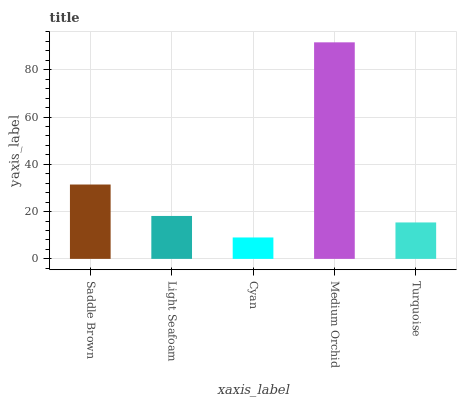Is Cyan the minimum?
Answer yes or no. Yes. Is Medium Orchid the maximum?
Answer yes or no. Yes. Is Light Seafoam the minimum?
Answer yes or no. No. Is Light Seafoam the maximum?
Answer yes or no. No. Is Saddle Brown greater than Light Seafoam?
Answer yes or no. Yes. Is Light Seafoam less than Saddle Brown?
Answer yes or no. Yes. Is Light Seafoam greater than Saddle Brown?
Answer yes or no. No. Is Saddle Brown less than Light Seafoam?
Answer yes or no. No. Is Light Seafoam the high median?
Answer yes or no. Yes. Is Light Seafoam the low median?
Answer yes or no. Yes. Is Medium Orchid the high median?
Answer yes or no. No. Is Saddle Brown the low median?
Answer yes or no. No. 